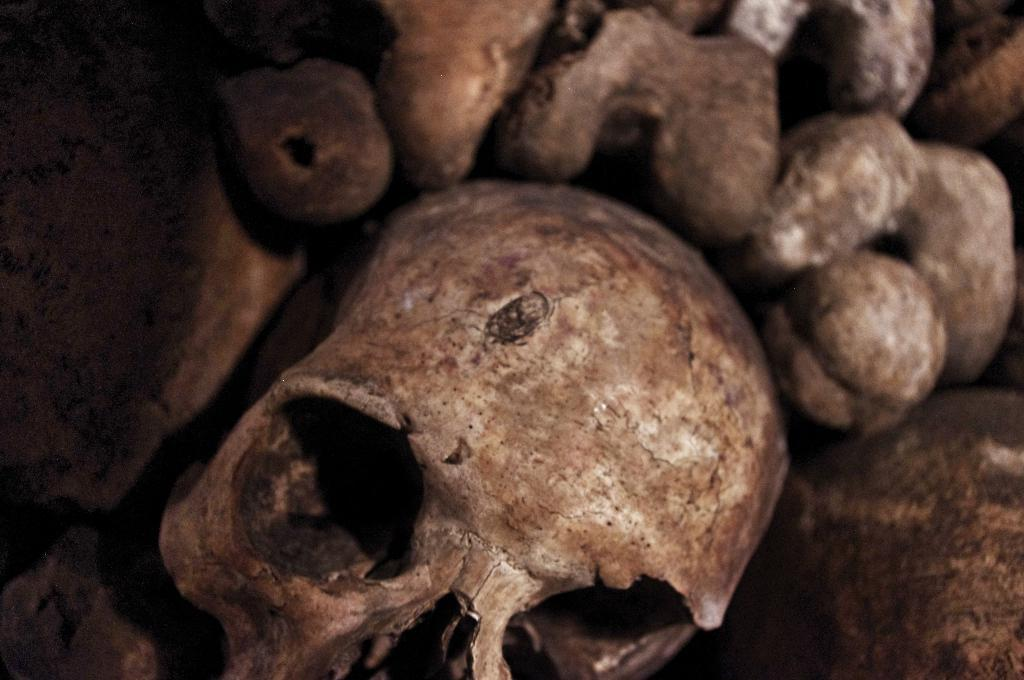What is the main subject of the image? The main subject of the image is a skull. Are there any other related objects in the image? Yes, there are bones in the image. What type of glue is being used to hold the bones together in the image? There is no glue present in the image; the bones and skull are depicted as they are. Can you hear the skull and bones in the image? The image is a visual representation, so there is no sound associated with it, and therefore, you cannot hear the skull and bones. 